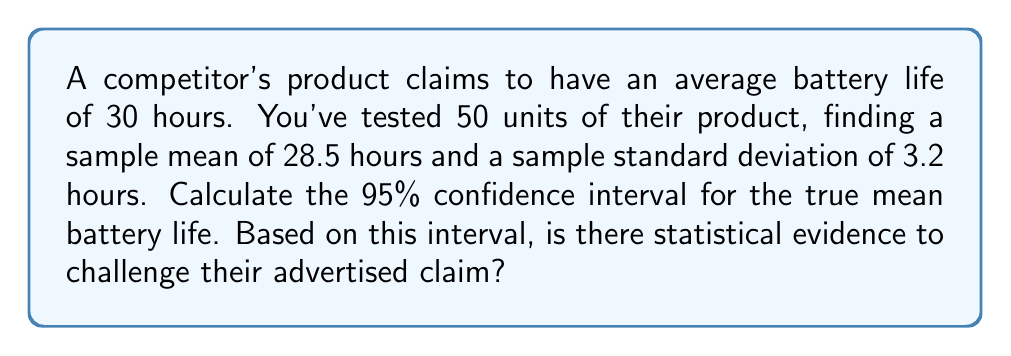Solve this math problem. To calculate the 95% confidence interval for the true mean battery life, we'll use the t-distribution since we're working with a sample size less than 30 and don't know the population standard deviation.

Step 1: Identify the known values
- Sample size: $n = 50$
- Sample mean: $\bar{x} = 28.5$ hours
- Sample standard deviation: $s = 3.2$ hours
- Confidence level: 95% (α = 0.05)

Step 2: Determine the critical t-value
With 49 degrees of freedom (n - 1) and α = 0.05 for a two-tailed test, the critical t-value is approximately 2.01 (from t-distribution table).

Step 3: Calculate the margin of error
Margin of error = $t_{\frac{\alpha}{2}, n-1} \cdot \frac{s}{\sqrt{n}}$
$= 2.01 \cdot \frac{3.2}{\sqrt{50}} = 0.91$

Step 4: Compute the confidence interval
Lower bound = $\bar{x} - \text{margin of error} = 28.5 - 0.91 = 27.59$
Upper bound = $\bar{x} + \text{margin of error} = 28.5 + 0.91 = 29.41$

The 95% confidence interval is (27.59, 29.41) hours.

Step 5: Assess the claim
The advertised claim of 30 hours falls outside this confidence interval, providing statistical evidence to challenge their claim.
Answer: 95% CI: (27.59, 29.41) hours; Evidence to challenge the 30-hour claim. 